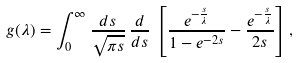<formula> <loc_0><loc_0><loc_500><loc_500>g ( \lambda ) = \int _ { 0 } ^ { \infty } \frac { d s } { \sqrt { \pi s } } \, \frac { d } { d s } \, \left [ \frac { e ^ { - \frac { s } { \lambda } } } { 1 - e ^ { - 2 s } } - \frac { e ^ { - \frac { s } { \lambda } } } { 2 s } \right ] ,</formula> 